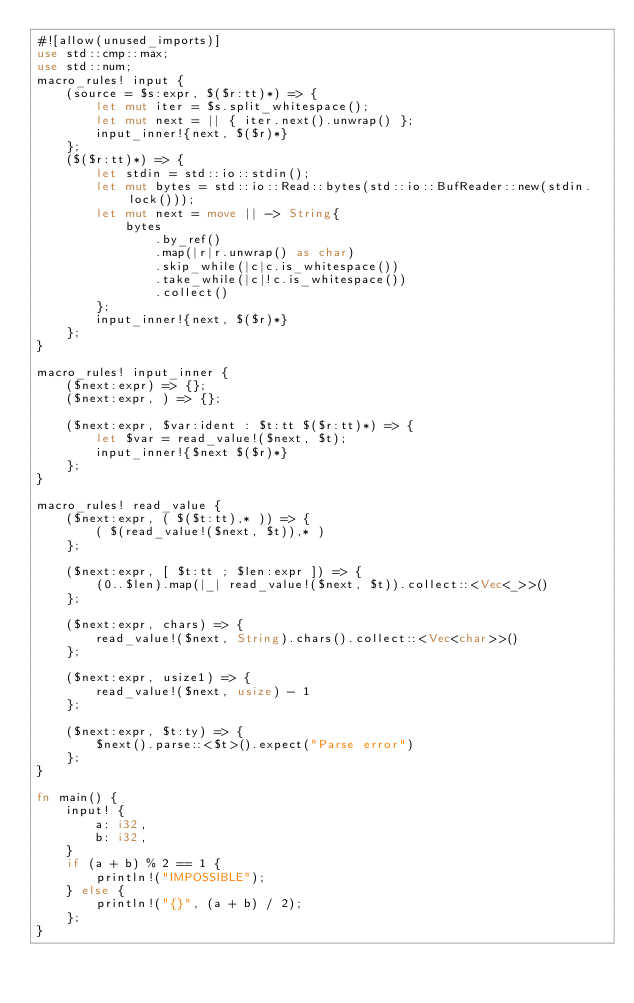Convert code to text. <code><loc_0><loc_0><loc_500><loc_500><_Rust_>#![allow(unused_imports)]
use std::cmp::max;
use std::num;
macro_rules! input {
    (source = $s:expr, $($r:tt)*) => {
        let mut iter = $s.split_whitespace();
        let mut next = || { iter.next().unwrap() };
        input_inner!{next, $($r)*}
    };
    ($($r:tt)*) => {
        let stdin = std::io::stdin();
        let mut bytes = std::io::Read::bytes(std::io::BufReader::new(stdin.lock()));
        let mut next = move || -> String{
            bytes
                .by_ref()
                .map(|r|r.unwrap() as char)
                .skip_while(|c|c.is_whitespace())
                .take_while(|c|!c.is_whitespace())
                .collect()
        };
        input_inner!{next, $($r)*}
    };
}

macro_rules! input_inner {
    ($next:expr) => {};
    ($next:expr, ) => {};

    ($next:expr, $var:ident : $t:tt $($r:tt)*) => {
        let $var = read_value!($next, $t);
        input_inner!{$next $($r)*}
    };
}

macro_rules! read_value {
    ($next:expr, ( $($t:tt),* )) => {
        ( $(read_value!($next, $t)),* )
    };

    ($next:expr, [ $t:tt ; $len:expr ]) => {
        (0..$len).map(|_| read_value!($next, $t)).collect::<Vec<_>>()
    };

    ($next:expr, chars) => {
        read_value!($next, String).chars().collect::<Vec<char>>()
    };

    ($next:expr, usize1) => {
        read_value!($next, usize) - 1
    };

    ($next:expr, $t:ty) => {
        $next().parse::<$t>().expect("Parse error")
    };
}

fn main() {
    input! {
        a: i32,
        b: i32,
    }
    if (a + b) % 2 == 1 {
        println!("IMPOSSIBLE");
    } else {
        println!("{}", (a + b) / 2);
    };
}
</code> 